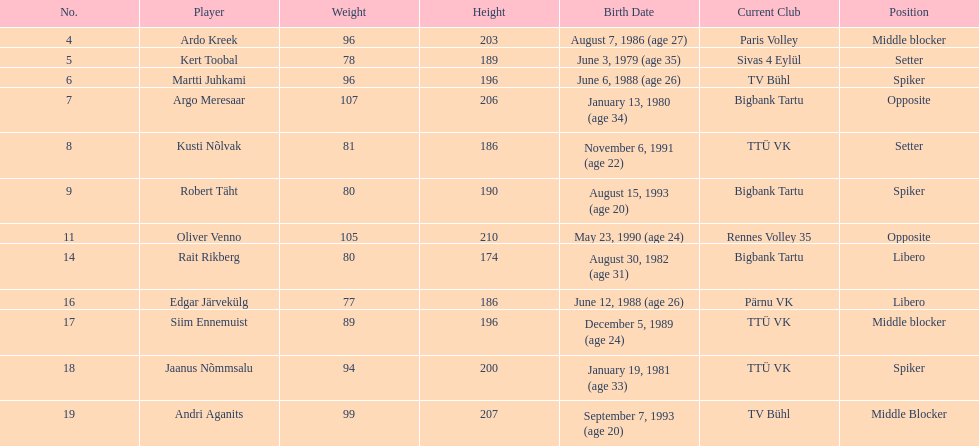How many players are middle blockers? 3. 